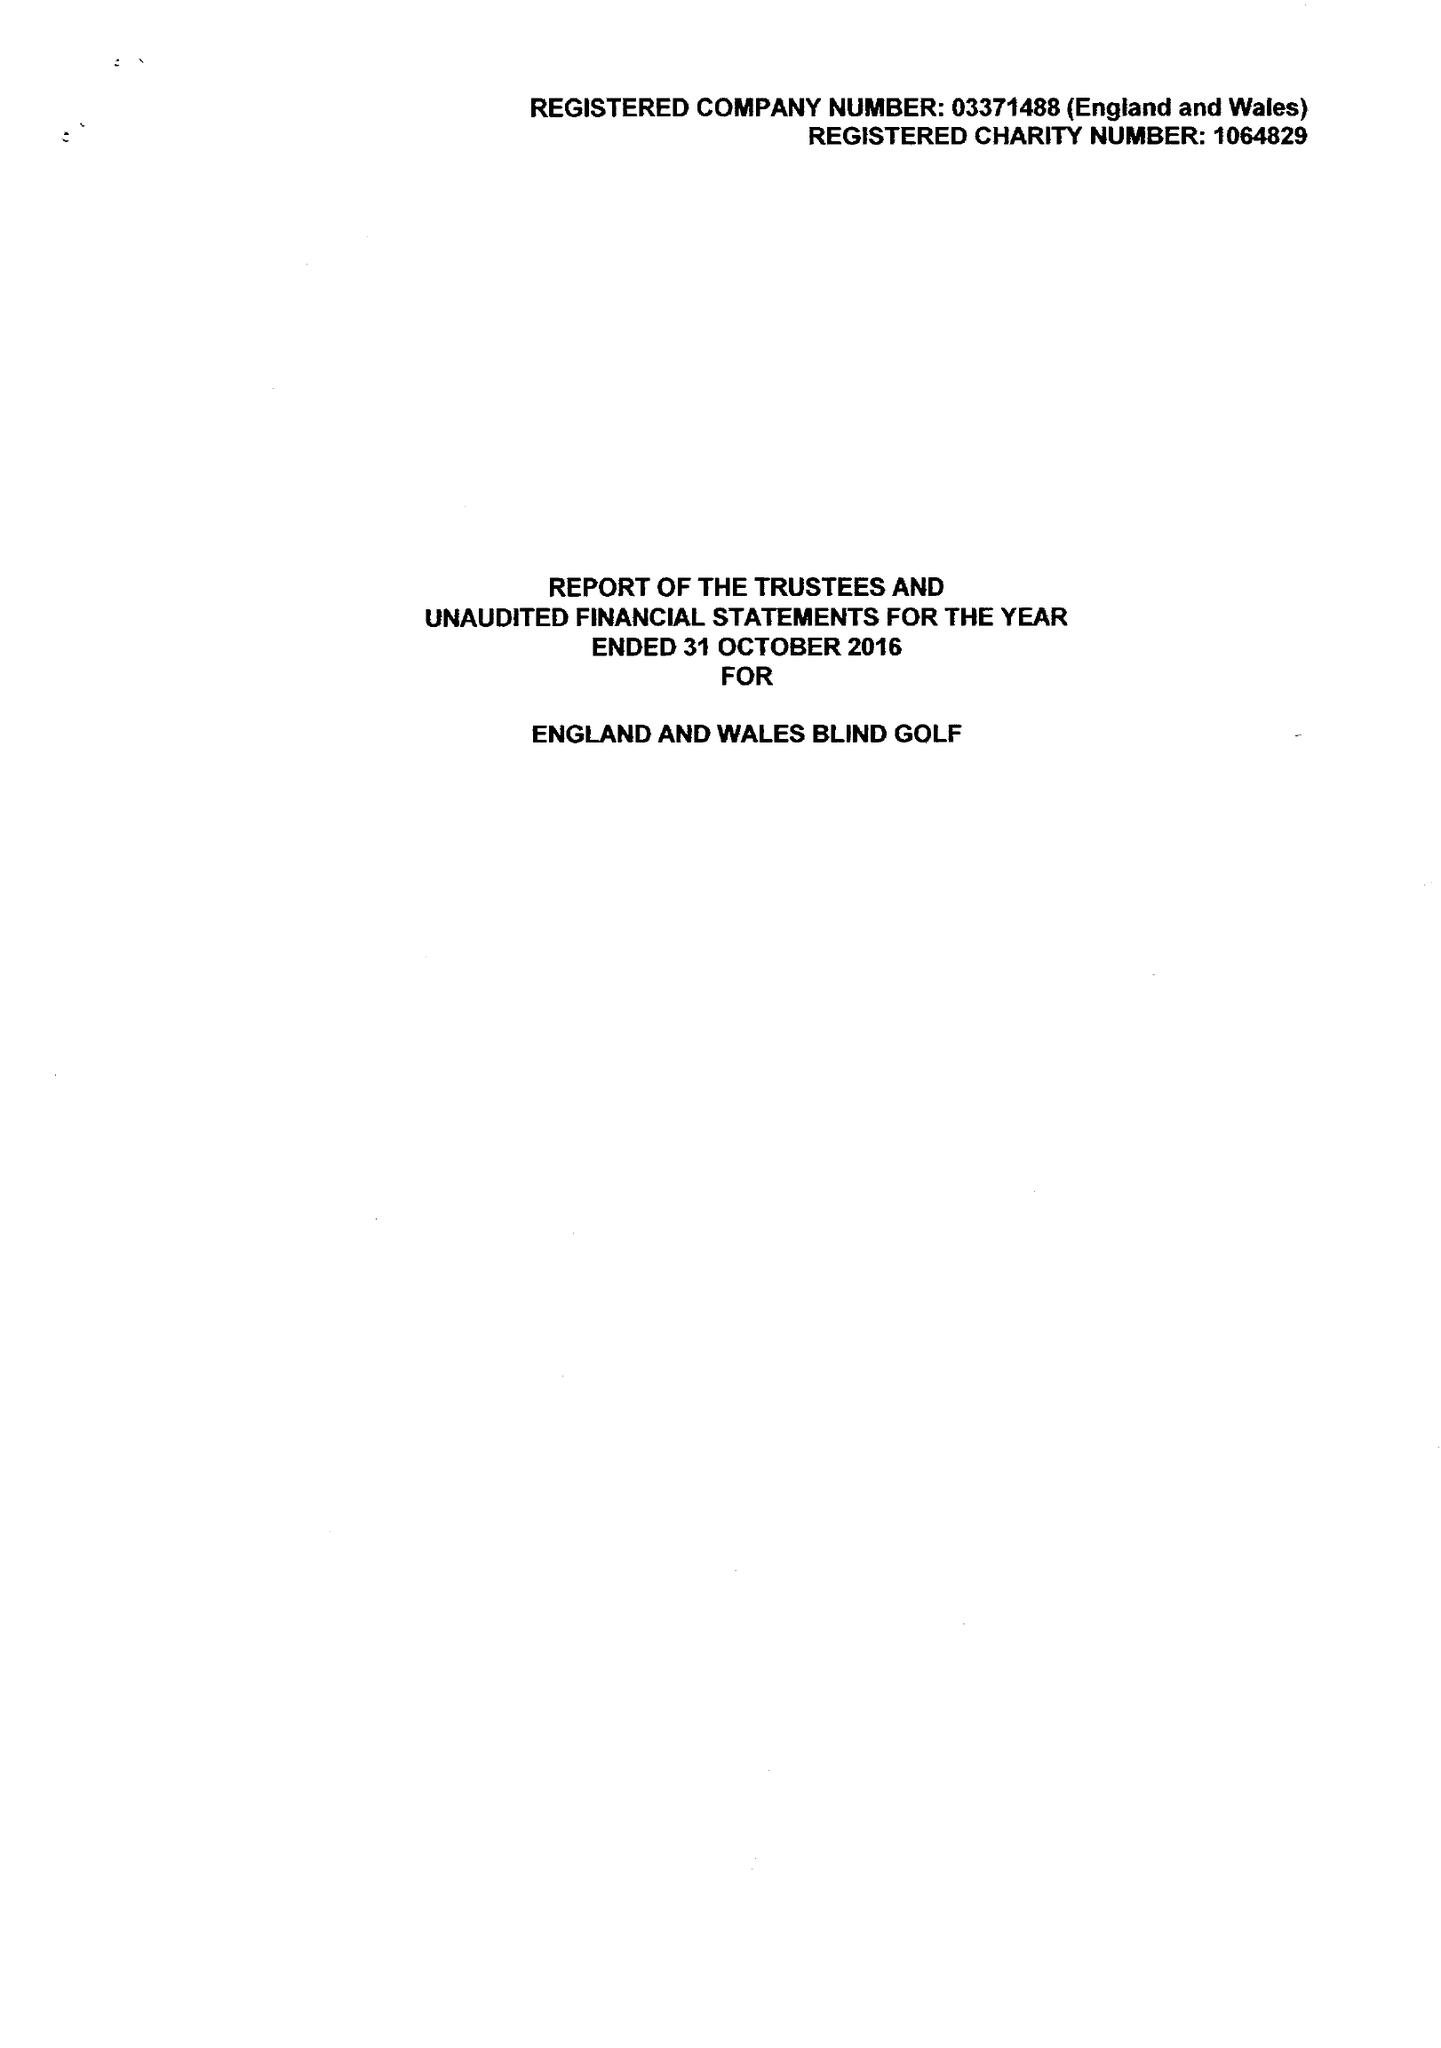What is the value for the income_annually_in_british_pounds?
Answer the question using a single word or phrase. 125421.00 